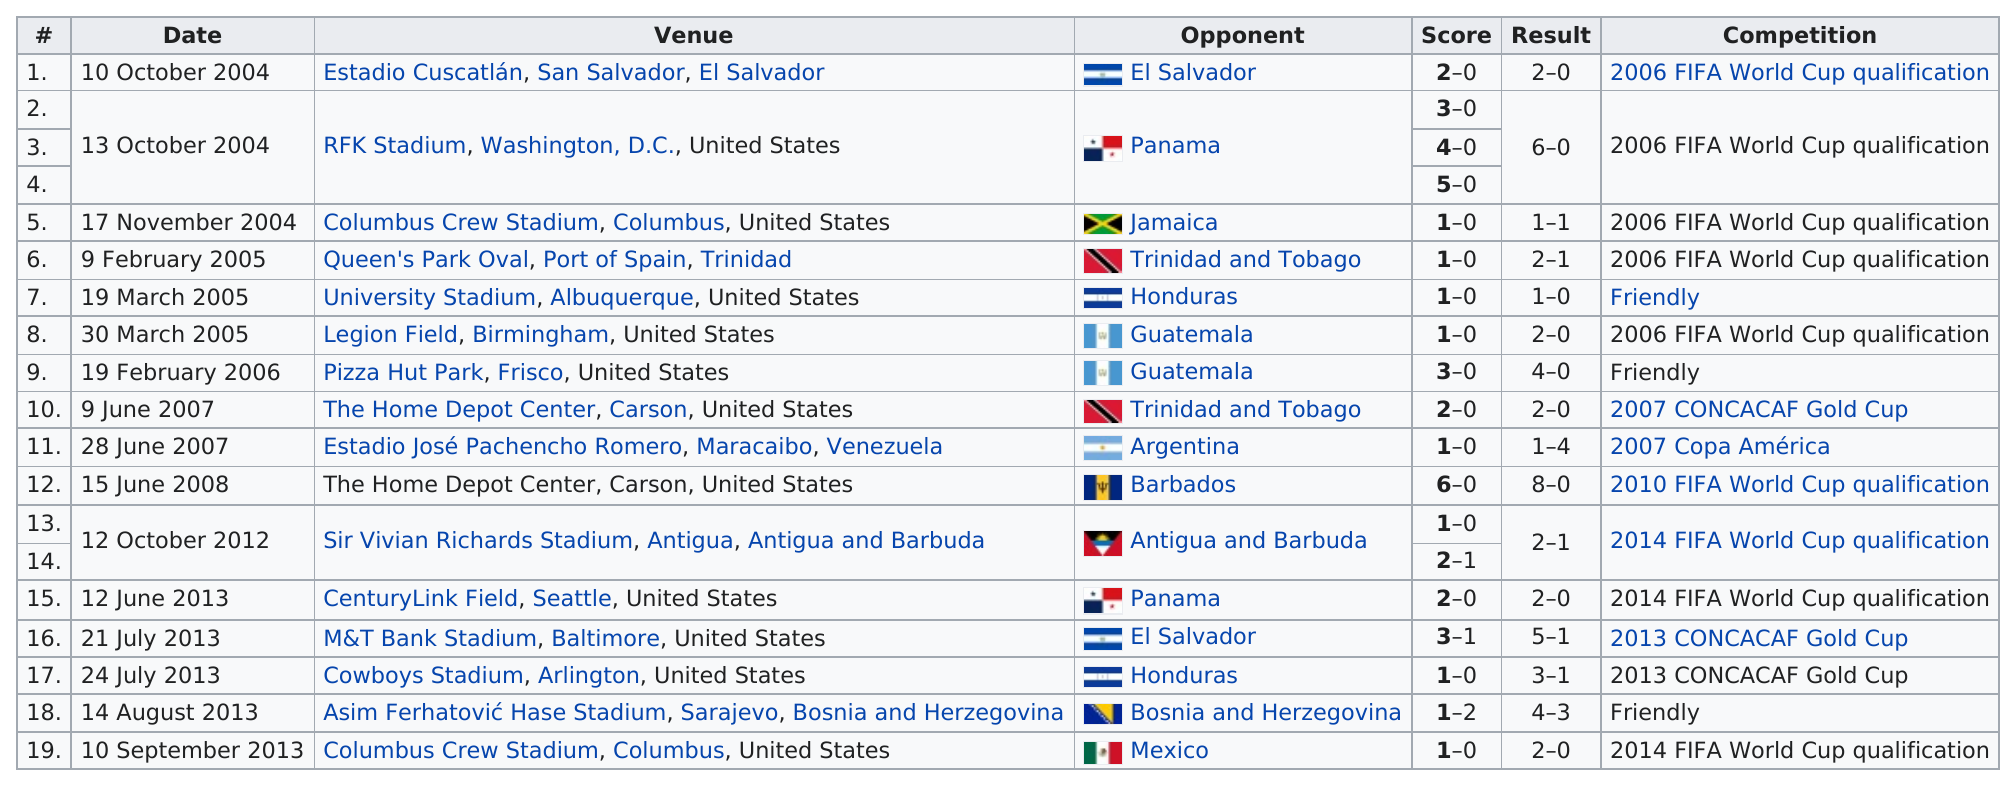List a handful of essential elements in this visual. The speaker last competed in Columbus Crew Stadium in Columbus, United States. In 2013, the last venue played at was the Columbus Crew Stadium. The date of September 10th is next to the venue of Columbus Crew Stadium, located in Columbus, United States. Guatemala achieved two consecutive wins. He has played against Honduras two times. 